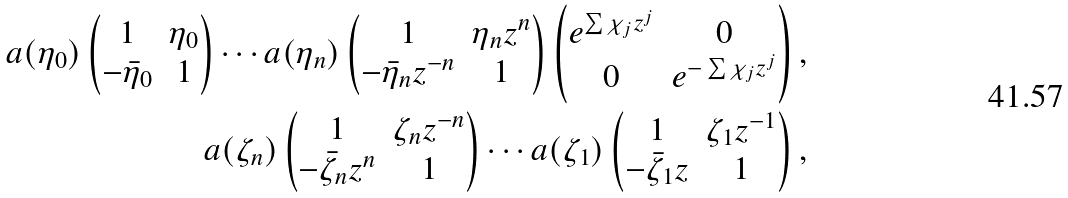Convert formula to latex. <formula><loc_0><loc_0><loc_500><loc_500>a ( \eta _ { 0 } ) \left ( \begin{matrix} 1 & \eta _ { 0 } \\ - \bar { \eta } _ { 0 } & 1 \end{matrix} \right ) \cdots a ( \eta _ { n } ) \left ( \begin{matrix} 1 & \eta _ { n } z ^ { n } \\ - \bar { \eta } _ { n } z ^ { - n } & 1 \end{matrix} \right ) \left ( \begin{matrix} e ^ { \sum \chi _ { j } z ^ { j } } & 0 \\ 0 & e ^ { - \sum \chi _ { j } z ^ { j } } \end{matrix} \right ) , \\ a ( \zeta _ { n } ) \left ( \begin{matrix} 1 & \zeta _ { n } z ^ { - n } \\ - \bar { \zeta } _ { n } z ^ { n } & 1 \end{matrix} \right ) \cdots a ( \zeta _ { 1 } ) \left ( \begin{matrix} 1 & \zeta _ { 1 } z ^ { - 1 } \\ - \bar { \zeta } _ { 1 } z & 1 \end{matrix} \right ) ,</formula> 